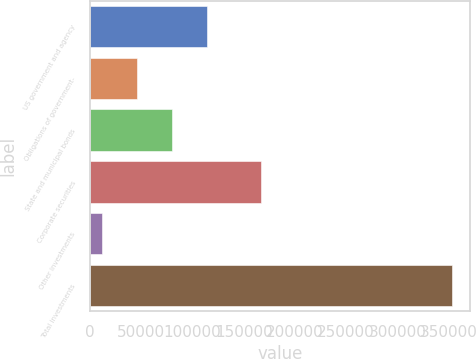Convert chart. <chart><loc_0><loc_0><loc_500><loc_500><bar_chart><fcel>US government and agency<fcel>Obligations of government-<fcel>State and municipal bonds<fcel>Corporate securities<fcel>Other investments<fcel>Total investments<nl><fcel>114172<fcel>45904.8<fcel>80038.6<fcel>166642<fcel>11771<fcel>353109<nl></chart> 